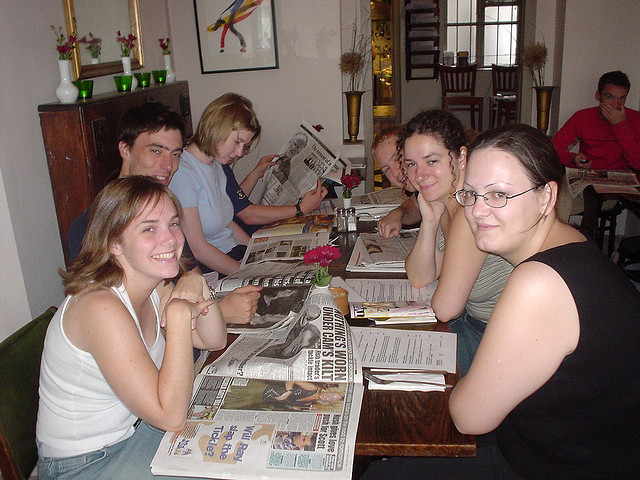Can you describe the mood of the people? The individuals seem to be relaxed and comfortable, possibly enjoying a casual gathering or a meal together. Their expressions range from smiling and content to focused on their reading material, indicating a laid-back atmosphere. 